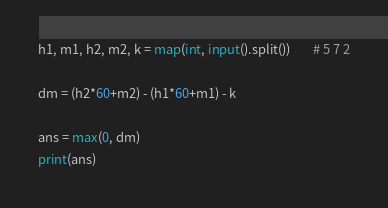Convert code to text. <code><loc_0><loc_0><loc_500><loc_500><_Python_>h1, m1, h2, m2, k = map(int, input().split())		# 5 7 2

dm = (h2*60+m2) - (h1*60+m1) - k

ans = max(0, dm)
print(ans)
</code> 